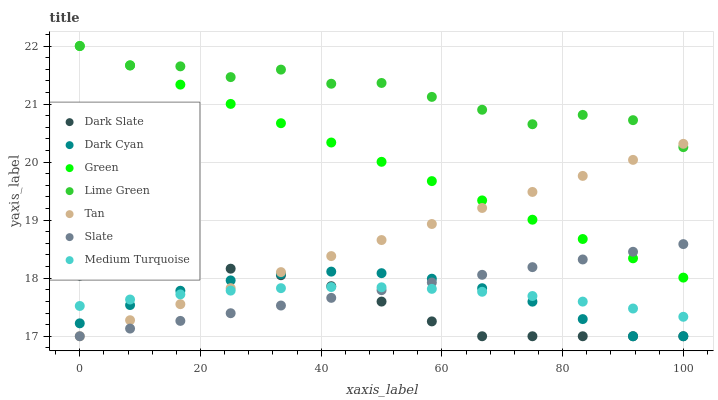Does Dark Slate have the minimum area under the curve?
Answer yes or no. Yes. Does Lime Green have the maximum area under the curve?
Answer yes or no. Yes. Does Green have the minimum area under the curve?
Answer yes or no. No. Does Green have the maximum area under the curve?
Answer yes or no. No. Is Slate the smoothest?
Answer yes or no. Yes. Is Lime Green the roughest?
Answer yes or no. Yes. Is Dark Slate the smoothest?
Answer yes or no. No. Is Dark Slate the roughest?
Answer yes or no. No. Does Slate have the lowest value?
Answer yes or no. Yes. Does Green have the lowest value?
Answer yes or no. No. Does Lime Green have the highest value?
Answer yes or no. Yes. Does Dark Slate have the highest value?
Answer yes or no. No. Is Dark Slate less than Green?
Answer yes or no. Yes. Is Lime Green greater than Medium Turquoise?
Answer yes or no. Yes. Does Slate intersect Tan?
Answer yes or no. Yes. Is Slate less than Tan?
Answer yes or no. No. Is Slate greater than Tan?
Answer yes or no. No. Does Dark Slate intersect Green?
Answer yes or no. No. 